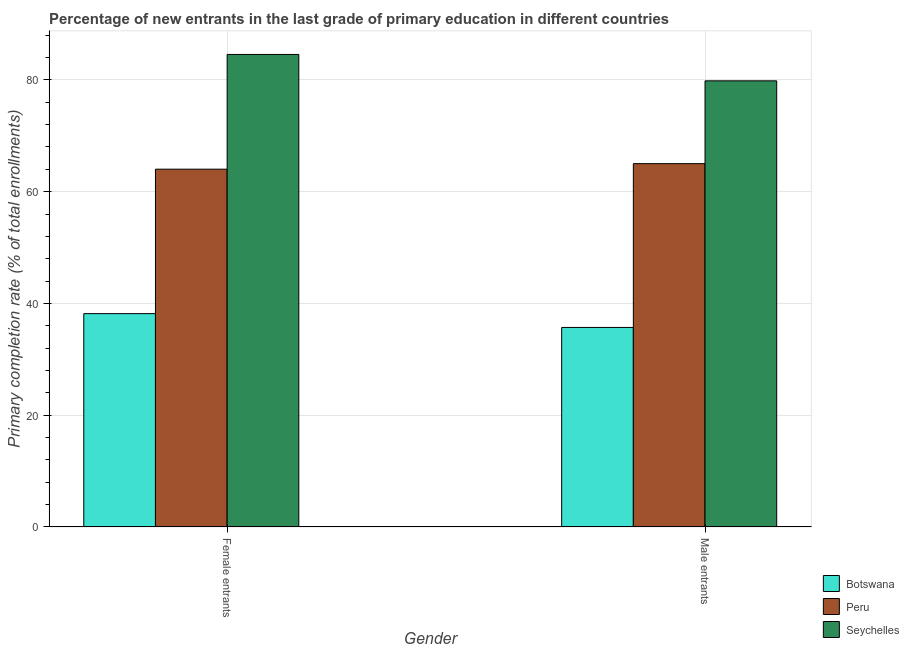How many groups of bars are there?
Your answer should be compact. 2. Are the number of bars on each tick of the X-axis equal?
Your answer should be very brief. Yes. How many bars are there on the 2nd tick from the left?
Offer a very short reply. 3. What is the label of the 1st group of bars from the left?
Your answer should be compact. Female entrants. What is the primary completion rate of female entrants in Peru?
Your answer should be compact. 64.03. Across all countries, what is the maximum primary completion rate of female entrants?
Make the answer very short. 84.56. Across all countries, what is the minimum primary completion rate of male entrants?
Give a very brief answer. 35.71. In which country was the primary completion rate of female entrants maximum?
Your answer should be compact. Seychelles. In which country was the primary completion rate of female entrants minimum?
Your answer should be very brief. Botswana. What is the total primary completion rate of male entrants in the graph?
Your answer should be compact. 180.57. What is the difference between the primary completion rate of male entrants in Seychelles and that in Botswana?
Provide a short and direct response. 44.13. What is the difference between the primary completion rate of female entrants in Peru and the primary completion rate of male entrants in Botswana?
Provide a short and direct response. 28.32. What is the average primary completion rate of female entrants per country?
Your answer should be compact. 62.26. What is the difference between the primary completion rate of female entrants and primary completion rate of male entrants in Peru?
Provide a short and direct response. -0.99. In how many countries, is the primary completion rate of male entrants greater than 40 %?
Offer a very short reply. 2. What is the ratio of the primary completion rate of female entrants in Peru to that in Seychelles?
Offer a terse response. 0.76. Is the primary completion rate of female entrants in Peru less than that in Botswana?
Your answer should be very brief. No. In how many countries, is the primary completion rate of male entrants greater than the average primary completion rate of male entrants taken over all countries?
Your answer should be very brief. 2. What does the 1st bar from the right in Female entrants represents?
Provide a succinct answer. Seychelles. Are all the bars in the graph horizontal?
Your response must be concise. No. How many countries are there in the graph?
Your answer should be compact. 3. What is the difference between two consecutive major ticks on the Y-axis?
Your answer should be very brief. 20. How are the legend labels stacked?
Offer a very short reply. Vertical. What is the title of the graph?
Provide a succinct answer. Percentage of new entrants in the last grade of primary education in different countries. What is the label or title of the X-axis?
Your answer should be compact. Gender. What is the label or title of the Y-axis?
Offer a very short reply. Primary completion rate (% of total enrollments). What is the Primary completion rate (% of total enrollments) in Botswana in Female entrants?
Ensure brevity in your answer.  38.18. What is the Primary completion rate (% of total enrollments) in Peru in Female entrants?
Provide a succinct answer. 64.03. What is the Primary completion rate (% of total enrollments) of Seychelles in Female entrants?
Your answer should be compact. 84.56. What is the Primary completion rate (% of total enrollments) in Botswana in Male entrants?
Keep it short and to the point. 35.71. What is the Primary completion rate (% of total enrollments) of Peru in Male entrants?
Provide a short and direct response. 65.02. What is the Primary completion rate (% of total enrollments) of Seychelles in Male entrants?
Make the answer very short. 79.84. Across all Gender, what is the maximum Primary completion rate (% of total enrollments) in Botswana?
Your response must be concise. 38.18. Across all Gender, what is the maximum Primary completion rate (% of total enrollments) of Peru?
Offer a very short reply. 65.02. Across all Gender, what is the maximum Primary completion rate (% of total enrollments) of Seychelles?
Keep it short and to the point. 84.56. Across all Gender, what is the minimum Primary completion rate (% of total enrollments) of Botswana?
Offer a terse response. 35.71. Across all Gender, what is the minimum Primary completion rate (% of total enrollments) of Peru?
Ensure brevity in your answer.  64.03. Across all Gender, what is the minimum Primary completion rate (% of total enrollments) of Seychelles?
Your answer should be very brief. 79.84. What is the total Primary completion rate (% of total enrollments) of Botswana in the graph?
Offer a very short reply. 73.89. What is the total Primary completion rate (% of total enrollments) of Peru in the graph?
Ensure brevity in your answer.  129.06. What is the total Primary completion rate (% of total enrollments) in Seychelles in the graph?
Make the answer very short. 164.4. What is the difference between the Primary completion rate (% of total enrollments) of Botswana in Female entrants and that in Male entrants?
Give a very brief answer. 2.47. What is the difference between the Primary completion rate (% of total enrollments) of Peru in Female entrants and that in Male entrants?
Your response must be concise. -0.99. What is the difference between the Primary completion rate (% of total enrollments) in Seychelles in Female entrants and that in Male entrants?
Provide a succinct answer. 4.72. What is the difference between the Primary completion rate (% of total enrollments) of Botswana in Female entrants and the Primary completion rate (% of total enrollments) of Peru in Male entrants?
Your answer should be compact. -26.84. What is the difference between the Primary completion rate (% of total enrollments) of Botswana in Female entrants and the Primary completion rate (% of total enrollments) of Seychelles in Male entrants?
Your answer should be compact. -41.66. What is the difference between the Primary completion rate (% of total enrollments) of Peru in Female entrants and the Primary completion rate (% of total enrollments) of Seychelles in Male entrants?
Your answer should be very brief. -15.81. What is the average Primary completion rate (% of total enrollments) in Botswana per Gender?
Provide a succinct answer. 36.95. What is the average Primary completion rate (% of total enrollments) of Peru per Gender?
Provide a short and direct response. 64.53. What is the average Primary completion rate (% of total enrollments) in Seychelles per Gender?
Keep it short and to the point. 82.2. What is the difference between the Primary completion rate (% of total enrollments) of Botswana and Primary completion rate (% of total enrollments) of Peru in Female entrants?
Ensure brevity in your answer.  -25.85. What is the difference between the Primary completion rate (% of total enrollments) in Botswana and Primary completion rate (% of total enrollments) in Seychelles in Female entrants?
Provide a short and direct response. -46.38. What is the difference between the Primary completion rate (% of total enrollments) of Peru and Primary completion rate (% of total enrollments) of Seychelles in Female entrants?
Ensure brevity in your answer.  -20.53. What is the difference between the Primary completion rate (% of total enrollments) of Botswana and Primary completion rate (% of total enrollments) of Peru in Male entrants?
Your answer should be very brief. -29.31. What is the difference between the Primary completion rate (% of total enrollments) of Botswana and Primary completion rate (% of total enrollments) of Seychelles in Male entrants?
Offer a very short reply. -44.13. What is the difference between the Primary completion rate (% of total enrollments) in Peru and Primary completion rate (% of total enrollments) in Seychelles in Male entrants?
Your response must be concise. -14.81. What is the ratio of the Primary completion rate (% of total enrollments) of Botswana in Female entrants to that in Male entrants?
Your answer should be compact. 1.07. What is the ratio of the Primary completion rate (% of total enrollments) in Peru in Female entrants to that in Male entrants?
Your answer should be compact. 0.98. What is the ratio of the Primary completion rate (% of total enrollments) in Seychelles in Female entrants to that in Male entrants?
Your answer should be very brief. 1.06. What is the difference between the highest and the second highest Primary completion rate (% of total enrollments) of Botswana?
Your answer should be compact. 2.47. What is the difference between the highest and the second highest Primary completion rate (% of total enrollments) of Seychelles?
Provide a succinct answer. 4.72. What is the difference between the highest and the lowest Primary completion rate (% of total enrollments) in Botswana?
Your response must be concise. 2.47. What is the difference between the highest and the lowest Primary completion rate (% of total enrollments) of Peru?
Make the answer very short. 0.99. What is the difference between the highest and the lowest Primary completion rate (% of total enrollments) of Seychelles?
Offer a very short reply. 4.72. 